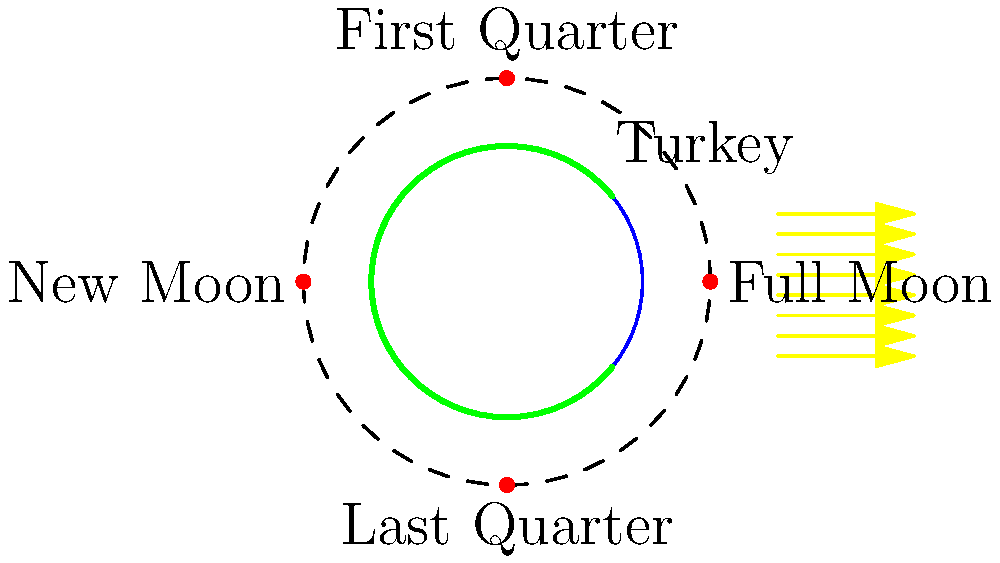As a traveler who has visited Turkey, you might have noticed differences in how the moon appears compared to other latitudes. Consider Turkey's latitude of approximately 39°N. How does this affect the visibility and appearance of the moon's phases compared to locations closer to the equator? To understand how Turkey's latitude affects the visibility and appearance of the moon's phases, let's break it down step-by-step:

1. Moon phases are caused by the relative positions of the Earth, Moon, and Sun. These phases are the same globally, but their appearance can differ based on the observer's latitude.

2. Turkey's latitude (39°N) is closer to the mid-latitudes than the equator. This affects how the moon appears in the sky:

   a. Moon's path in the sky: At mid-latitudes, the moon's path is more inclined relative to the horizon compared to the equator. This means the moon rises and sets at a greater angle.

   b. Visibility duration: The moon is visible for longer periods during certain phases at higher latitudes.

3. Specific effects on moon phases as seen from Turkey:

   a. Crescent moon: The crescent appears more "tilted" compared to equatorial views. The illuminated curve points more upward rather than to the side.

   b. "Cheshire Cat" effect: During first and last quarter phases, the "smile" of the moon appears more U-shaped than C-shaped.

   c. Full moon: It appears higher in the sky during winter and lower during summer, opposite to the sun's path.

4. Comparison to equatorial regions:
   
   a. At the equator, the moon's path is more perpendicular to the horizon.
   
   b. Crescent moons appear more "boat-shaped" at the equator.
   
   c. The duration of moonlight is more consistent throughout the year at the equator.

5. Cultural significance: In Islamic countries like Turkey, the crescent moon has special importance. The tilted appearance of the crescent at this latitude has influenced religious symbolism and calendars.

These differences, while subtle, contribute to the unique celestial experience one might have when observing the moon from Turkey compared to locations closer to the equator.
Answer: Tilted crescent, U-shaped quarters, variable full moon height 